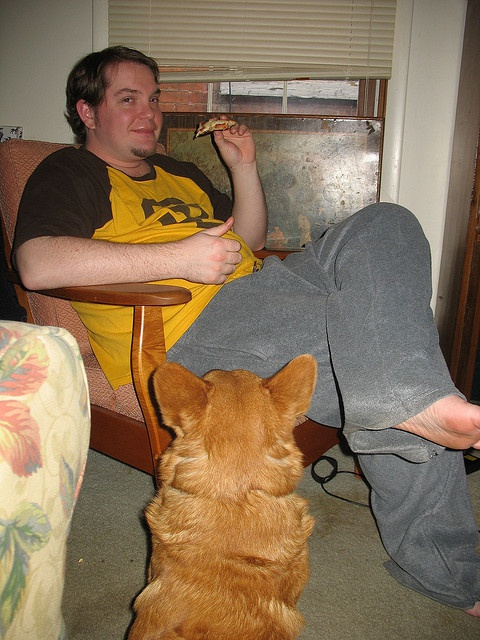Describe the objects in this image and their specific colors. I can see people in black, gray, and brown tones, dog in black, red, and tan tones, chair in black, maroon, and brown tones, and pizza in black, tan, maroon, and gray tones in this image. 